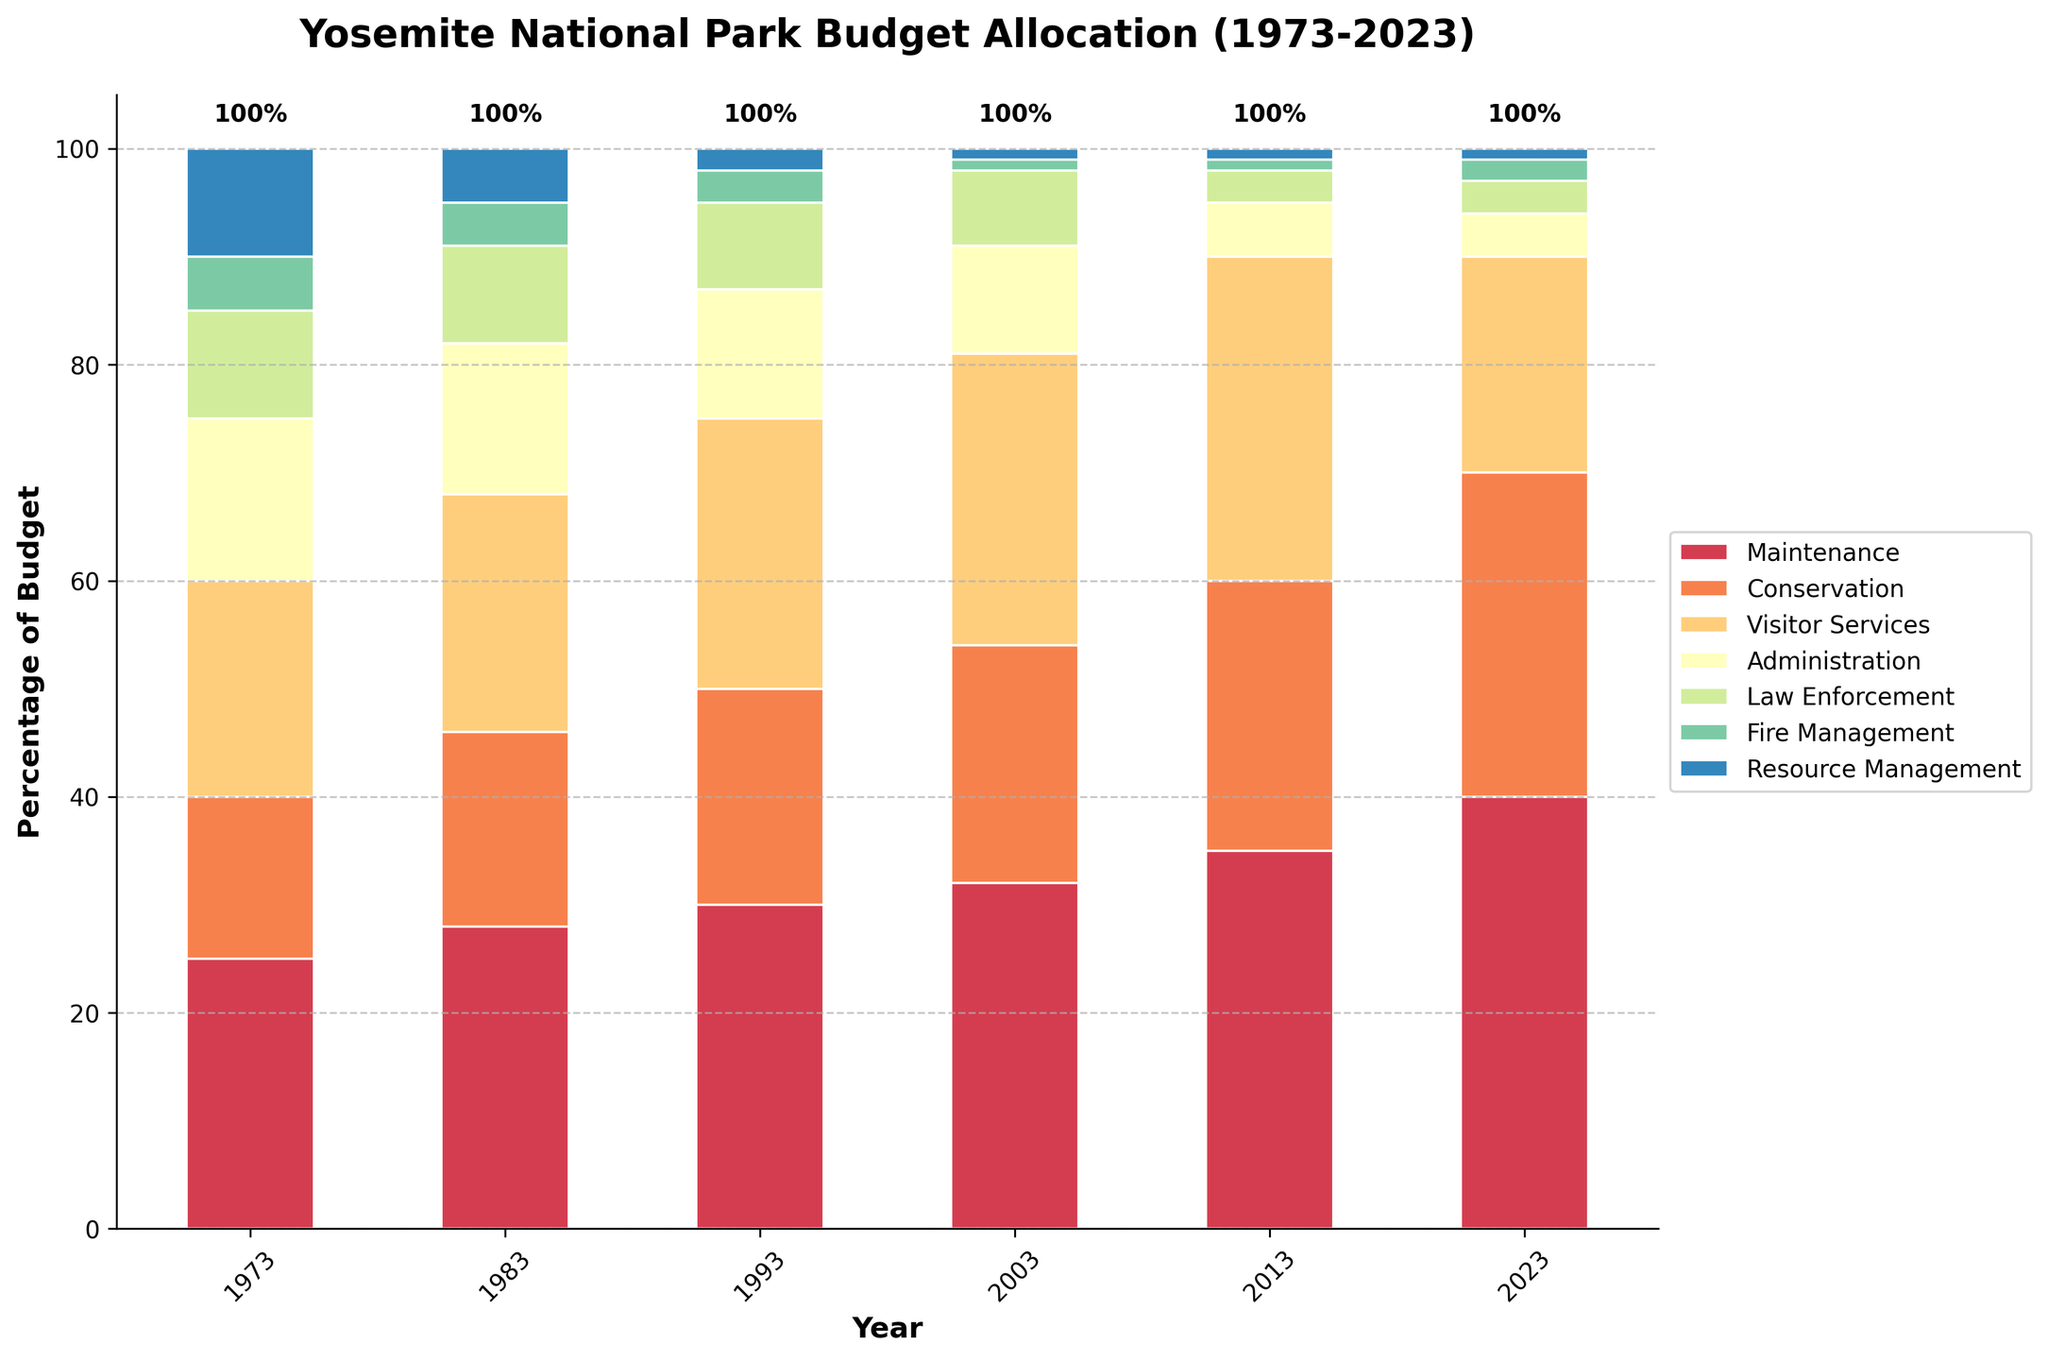Which year had the highest allocation for Maintenance? By observing the heights of the bars for Maintenance across all years, the year with the highest bar corresponds to the highest allocation. In this case, 2023 has the highest allocation for Maintenance as observed by its noticeably taller bar compared to other years.
Answer: 2023 What is the overall trend in budget allocation for Conservation from 1973 to 2023? To identify the trend, observe the heights of the Conservation bars for each year. The bars consistently increase from the lowest in 1973 to the highest in 2023, indicating an overall increasing trend.
Answer: Increasing Which department had a consistent allocation of 1% or less towards the recent years (2003 onwards)? To identify this, examine the heights of the bars for each department in the recent years (2003, 2013, and 2023). Only Fire Management and Resource Management maintain allocations around 1% from 2003 onwards.
Answer: Resource Management How does the allocation for Visitor Services in 1973 compare to 2023? Compare the heights of the Visitor Services bars in 1973 and 2023. The Visitor Services allocation significantly decreased from 20% in 1973 to 20% in 2023.
Answer: Decreased by 10% Sum of the allocations for Administration and Law Enforcement in 2013? Look at the heights of the Administration and Law Enforcement bars for 2013. The values are 5% and 3%, respectively. Adding these gives 5 + 3 = 8.
Answer: 8% Which two departments had the same allocation in 2023? Examine the heights of the bars for each department in 2023. Both Administration and Law Enforcement have equal allocations of 3%.
Answer: Administration and Law Enforcement Among Maintenance and Fire Management, which one shows a larger increase from 1973 to 2023? Calculate the difference between the 1973 and 2023 values for Maintenance (40-25=15) and for Fire Management (2-5=-3). Maintenance shows a larger increase.
Answer: Maintenance What is the difference in the allocation for Conservation between 1983 and 1993? Subtract the allocation values for Conservation in 1983 (18%) from that in 1993 (20%). The difference is 20 - 18 = 2.
Answer: 2% Average budget allocation for Law Enforcement over the last 50 years? Add up the allocations for Law Enforcement across all years: 10 + 9 + 8 + 7 + 3 + 3 = 40. Divide by the number of years (6). The average is 40/6 ≈ 6.67.
Answer: 6.67% What visual changes can you observe in the overall bar chart from 1973 to 2023? Notice the color and size changes in the department bars. Maintenance and Conservation bars increase significantly in height, while Visitor Services bars fluctuate but show a recent decrease. Lower sections (Fire and Resource Management) remain consistently small.
Answer: Increase in Maintenance and Conservation; decrease in Visitor Services; consistent lower allocations for Fire and Resource Management 